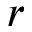<formula> <loc_0><loc_0><loc_500><loc_500>r</formula> 